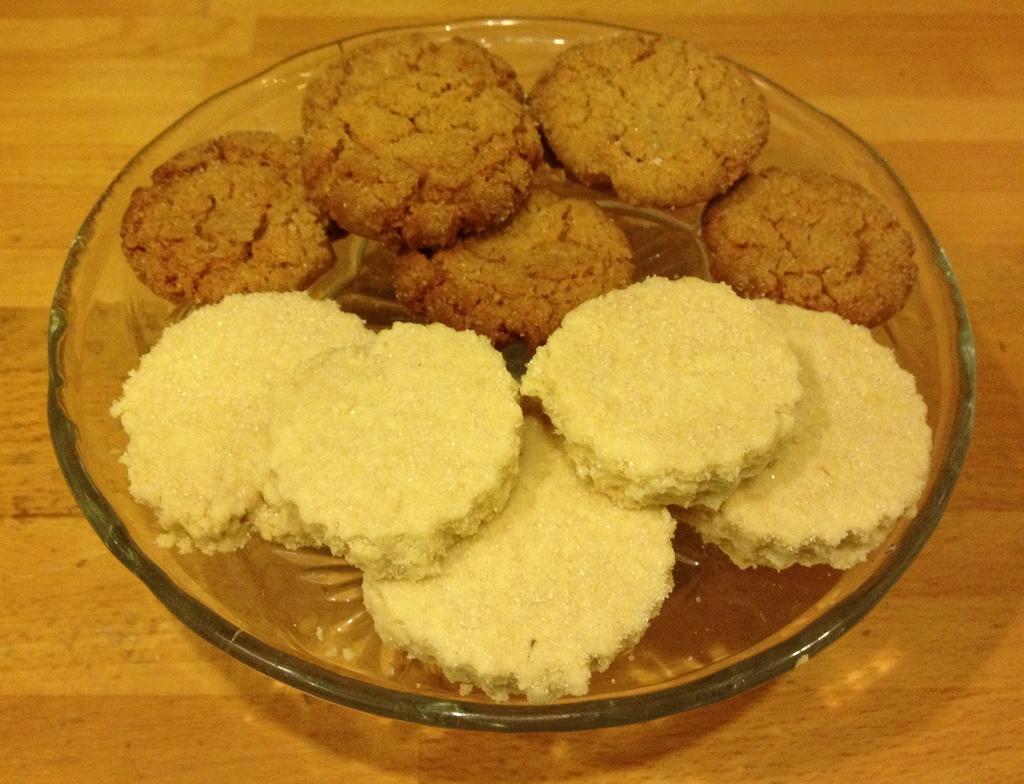In one or two sentences, can you explain what this image depicts? In this image in the center there is one plate, in that plate there are some cookies and at the bottom there is a table. 